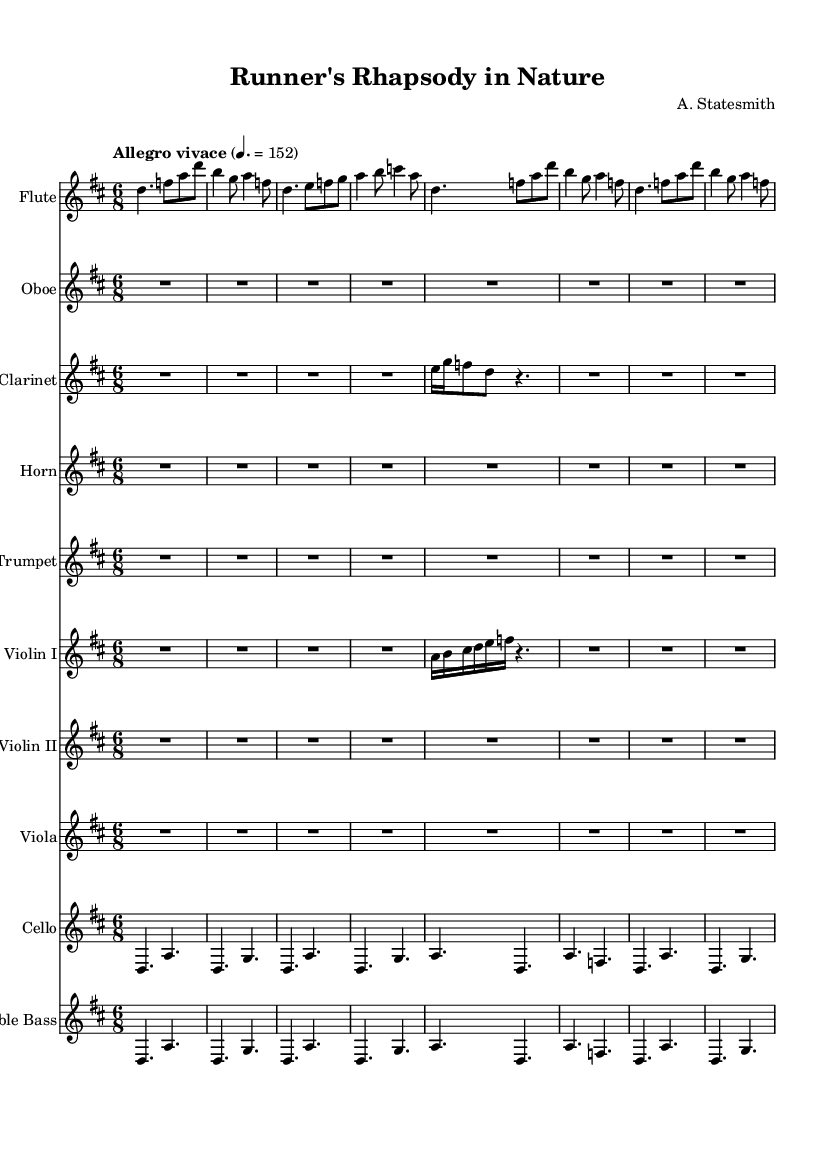What is the key signature of this music? The key signature indicated in the global settings of the sheet music is one sharp, which corresponds to D major.
Answer: D major What is the time signature of this piece? The time signature, as stated in the global settings, is 6/8, which means there are six eighth notes in each measure.
Answer: 6/8 What is the tempo marking given for the piece? The tempo marking specified in the global settings reads "Allegro vivace" at a tempo of quarter note = 152 beats per minute.
Answer: Allegro vivace How many instruments are there in this score? By counting the individual staves, we see there are ten different instrumental parts included in the score.
Answer: Ten Which instrument has a rest at the beginning of its part? The Oboe part starts with a rest indicated by "R2.*8", meaning it rests for a duration of two beats in eighth note value.
Answer: Oboe What is the relationship of 'd' to the other notes in the flute part? The note 'd' appears as a repeated note throughout the flute part, serving as a prominent melodic anchor in the phrase structure.
Answer: Repeated Does this composition reflect a Romantic era theme? The piece incorporates natural themes using a lively tempo and orchestration commonly found in Romantic music, emphasizing emotional expression and nature.
Answer: Yes 